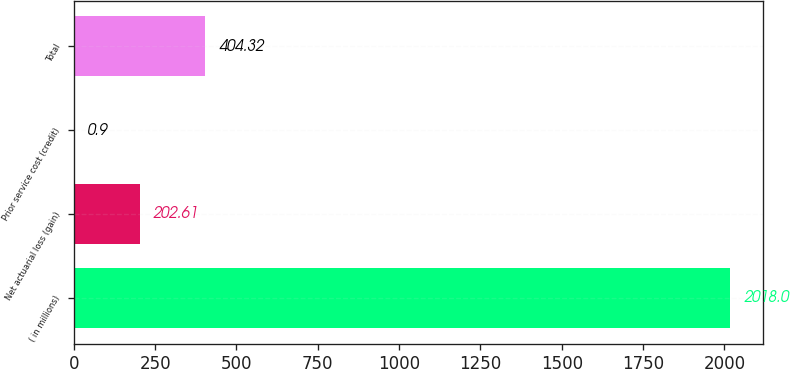<chart> <loc_0><loc_0><loc_500><loc_500><bar_chart><fcel>( in millions)<fcel>Net actuarial loss (gain)<fcel>Prior service cost (credit)<fcel>Total<nl><fcel>2018<fcel>202.61<fcel>0.9<fcel>404.32<nl></chart> 